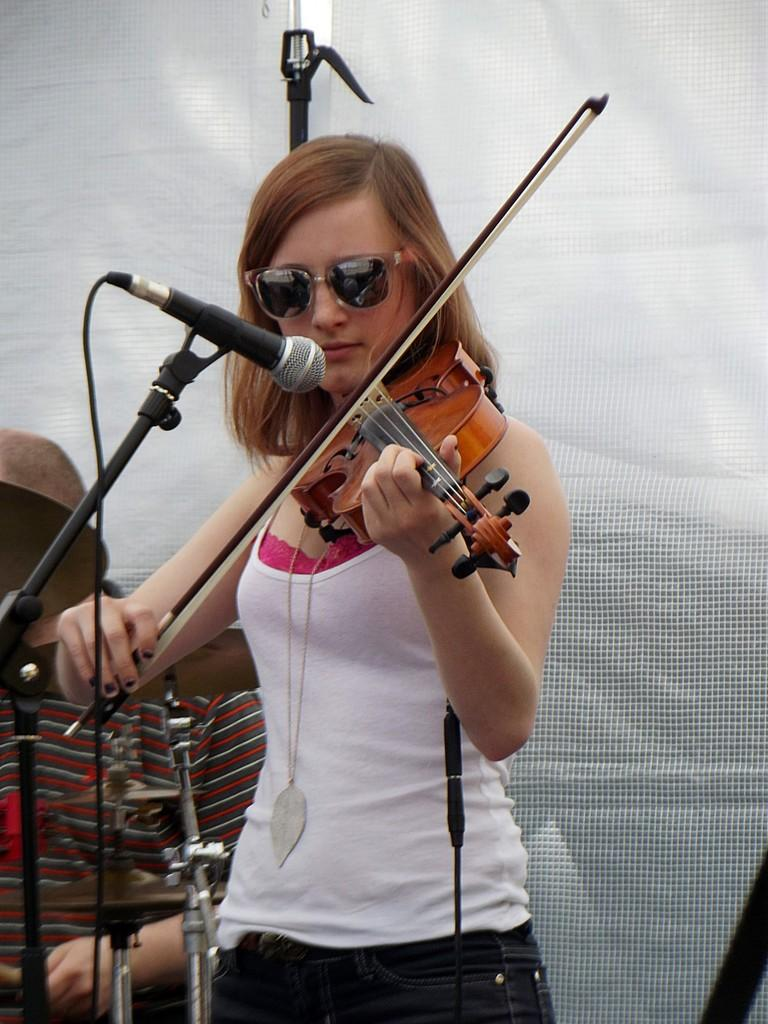What is the main subject of the image? There is a person in the image. What is the person wearing? The person is wearing a white dress. What is the person doing in the image? The person is playing a violin. What object is in front of the person? There is a microphone in front of the person. What discovery did the person's mother make while laughing in the image? There is no mention of a mother, discovery, or laughter in the image. The image only shows a person playing a violin with a microphone in front of them. 